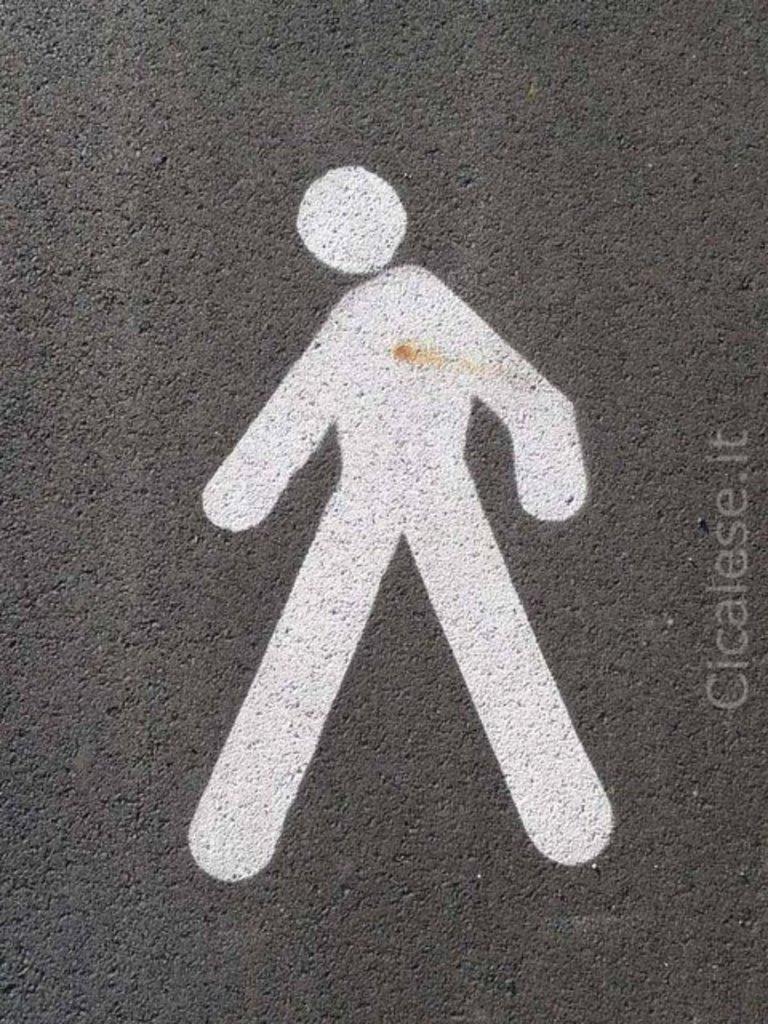In one or two sentences, can you explain what this image depicts? In this image, we can see a painting on the concrete surface and there is some text. 